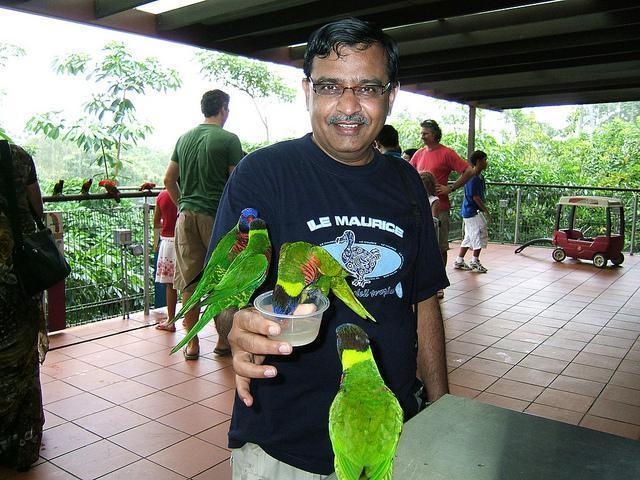How many birds are there in the picture?
Give a very brief answer. 4. How many birds can you see?
Give a very brief answer. 3. How many people are visible?
Give a very brief answer. 6. 